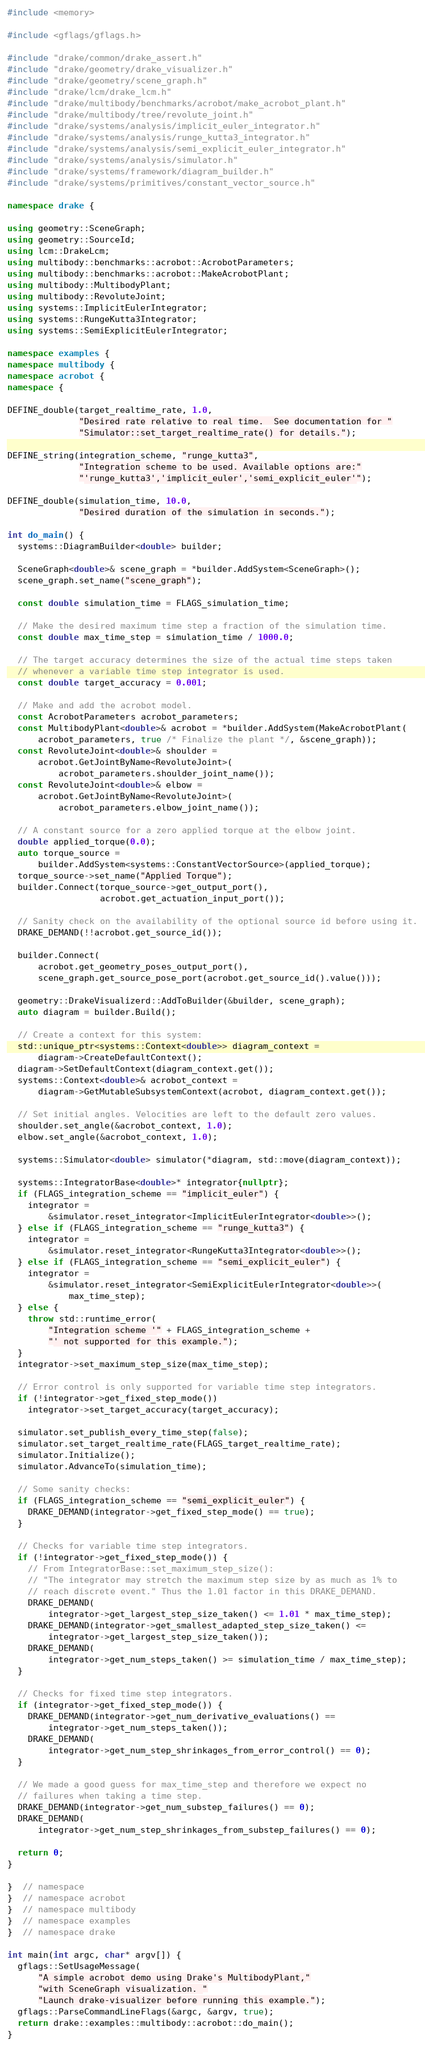Convert code to text. <code><loc_0><loc_0><loc_500><loc_500><_C++_>#include <memory>

#include <gflags/gflags.h>

#include "drake/common/drake_assert.h"
#include "drake/geometry/drake_visualizer.h"
#include "drake/geometry/scene_graph.h"
#include "drake/lcm/drake_lcm.h"
#include "drake/multibody/benchmarks/acrobot/make_acrobot_plant.h"
#include "drake/multibody/tree/revolute_joint.h"
#include "drake/systems/analysis/implicit_euler_integrator.h"
#include "drake/systems/analysis/runge_kutta3_integrator.h"
#include "drake/systems/analysis/semi_explicit_euler_integrator.h"
#include "drake/systems/analysis/simulator.h"
#include "drake/systems/framework/diagram_builder.h"
#include "drake/systems/primitives/constant_vector_source.h"

namespace drake {

using geometry::SceneGraph;
using geometry::SourceId;
using lcm::DrakeLcm;
using multibody::benchmarks::acrobot::AcrobotParameters;
using multibody::benchmarks::acrobot::MakeAcrobotPlant;
using multibody::MultibodyPlant;
using multibody::RevoluteJoint;
using systems::ImplicitEulerIntegrator;
using systems::RungeKutta3Integrator;
using systems::SemiExplicitEulerIntegrator;

namespace examples {
namespace multibody {
namespace acrobot {
namespace {

DEFINE_double(target_realtime_rate, 1.0,
              "Desired rate relative to real time.  See documentation for "
              "Simulator::set_target_realtime_rate() for details.");

DEFINE_string(integration_scheme, "runge_kutta3",
              "Integration scheme to be used. Available options are:"
              "'runge_kutta3','implicit_euler','semi_explicit_euler'");

DEFINE_double(simulation_time, 10.0,
              "Desired duration of the simulation in seconds.");

int do_main() {
  systems::DiagramBuilder<double> builder;

  SceneGraph<double>& scene_graph = *builder.AddSystem<SceneGraph>();
  scene_graph.set_name("scene_graph");

  const double simulation_time = FLAGS_simulation_time;

  // Make the desired maximum time step a fraction of the simulation time.
  const double max_time_step = simulation_time / 1000.0;

  // The target accuracy determines the size of the actual time steps taken
  // whenever a variable time step integrator is used.
  const double target_accuracy = 0.001;

  // Make and add the acrobot model.
  const AcrobotParameters acrobot_parameters;
  const MultibodyPlant<double>& acrobot = *builder.AddSystem(MakeAcrobotPlant(
      acrobot_parameters, true /* Finalize the plant */, &scene_graph));
  const RevoluteJoint<double>& shoulder =
      acrobot.GetJointByName<RevoluteJoint>(
          acrobot_parameters.shoulder_joint_name());
  const RevoluteJoint<double>& elbow =
      acrobot.GetJointByName<RevoluteJoint>(
          acrobot_parameters.elbow_joint_name());

  // A constant source for a zero applied torque at the elbow joint.
  double applied_torque(0.0);
  auto torque_source =
      builder.AddSystem<systems::ConstantVectorSource>(applied_torque);
  torque_source->set_name("Applied Torque");
  builder.Connect(torque_source->get_output_port(),
                  acrobot.get_actuation_input_port());

  // Sanity check on the availability of the optional source id before using it.
  DRAKE_DEMAND(!!acrobot.get_source_id());

  builder.Connect(
      acrobot.get_geometry_poses_output_port(),
      scene_graph.get_source_pose_port(acrobot.get_source_id().value()));

  geometry::DrakeVisualizerd::AddToBuilder(&builder, scene_graph);
  auto diagram = builder.Build();

  // Create a context for this system:
  std::unique_ptr<systems::Context<double>> diagram_context =
      diagram->CreateDefaultContext();
  diagram->SetDefaultContext(diagram_context.get());
  systems::Context<double>& acrobot_context =
      diagram->GetMutableSubsystemContext(acrobot, diagram_context.get());

  // Set initial angles. Velocities are left to the default zero values.
  shoulder.set_angle(&acrobot_context, 1.0);
  elbow.set_angle(&acrobot_context, 1.0);

  systems::Simulator<double> simulator(*diagram, std::move(diagram_context));

  systems::IntegratorBase<double>* integrator{nullptr};
  if (FLAGS_integration_scheme == "implicit_euler") {
    integrator =
        &simulator.reset_integrator<ImplicitEulerIntegrator<double>>();
  } else if (FLAGS_integration_scheme == "runge_kutta3") {
    integrator =
        &simulator.reset_integrator<RungeKutta3Integrator<double>>();
  } else if (FLAGS_integration_scheme == "semi_explicit_euler") {
    integrator =
        &simulator.reset_integrator<SemiExplicitEulerIntegrator<double>>(
            max_time_step);
  } else {
    throw std::runtime_error(
        "Integration scheme '" + FLAGS_integration_scheme +
        "' not supported for this example.");
  }
  integrator->set_maximum_step_size(max_time_step);

  // Error control is only supported for variable time step integrators.
  if (!integrator->get_fixed_step_mode())
    integrator->set_target_accuracy(target_accuracy);

  simulator.set_publish_every_time_step(false);
  simulator.set_target_realtime_rate(FLAGS_target_realtime_rate);
  simulator.Initialize();
  simulator.AdvanceTo(simulation_time);

  // Some sanity checks:
  if (FLAGS_integration_scheme == "semi_explicit_euler") {
    DRAKE_DEMAND(integrator->get_fixed_step_mode() == true);
  }

  // Checks for variable time step integrators.
  if (!integrator->get_fixed_step_mode()) {
    // From IntegratorBase::set_maximum_step_size():
    // "The integrator may stretch the maximum step size by as much as 1% to
    // reach discrete event." Thus the 1.01 factor in this DRAKE_DEMAND.
    DRAKE_DEMAND(
        integrator->get_largest_step_size_taken() <= 1.01 * max_time_step);
    DRAKE_DEMAND(integrator->get_smallest_adapted_step_size_taken() <=
        integrator->get_largest_step_size_taken());
    DRAKE_DEMAND(
        integrator->get_num_steps_taken() >= simulation_time / max_time_step);
  }

  // Checks for fixed time step integrators.
  if (integrator->get_fixed_step_mode()) {
    DRAKE_DEMAND(integrator->get_num_derivative_evaluations() ==
        integrator->get_num_steps_taken());
    DRAKE_DEMAND(
        integrator->get_num_step_shrinkages_from_error_control() == 0);
  }

  // We made a good guess for max_time_step and therefore we expect no
  // failures when taking a time step.
  DRAKE_DEMAND(integrator->get_num_substep_failures() == 0);
  DRAKE_DEMAND(
      integrator->get_num_step_shrinkages_from_substep_failures() == 0);

  return 0;
}

}  // namespace
}  // namespace acrobot
}  // namespace multibody
}  // namespace examples
}  // namespace drake

int main(int argc, char* argv[]) {
  gflags::SetUsageMessage(
      "A simple acrobot demo using Drake's MultibodyPlant,"
      "with SceneGraph visualization. "
      "Launch drake-visualizer before running this example.");
  gflags::ParseCommandLineFlags(&argc, &argv, true);
  return drake::examples::multibody::acrobot::do_main();
}
</code> 